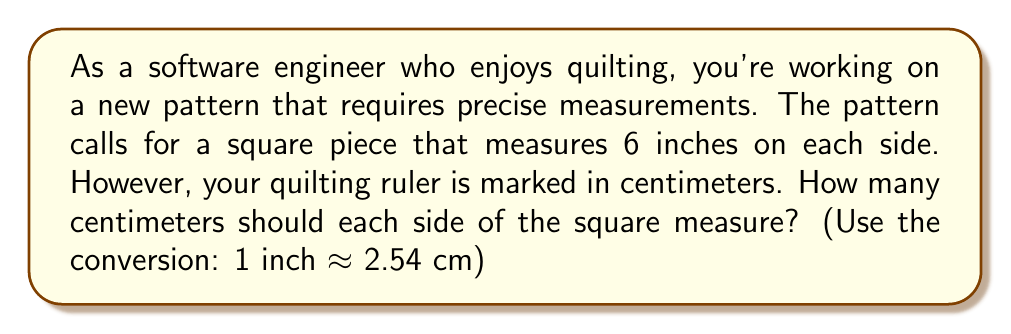Provide a solution to this math problem. To solve this problem, we need to convert 6 inches to centimeters. Let's break it down step-by-step:

1. We know that 1 inch is approximately equal to 2.54 centimeters.
   This can be expressed as a conversion factor: $1 \text{ inch} \approx 2.54 \text{ cm}$

2. We need to convert 6 inches to centimeters. We can set up the following proportion:
   $\frac{6 \text{ inches}}{1} = \frac{x \text{ cm}}{2.54 \text{ cm}}$

3. Cross-multiply to solve for $x$:
   $6 \cdot 2.54 = 1 \cdot x$

4. Simplify:
   $15.24 = x$

5. Therefore, 6 inches is equal to 15.24 centimeters.

To verify:
$6 \text{ inches} \cdot \frac{2.54 \text{ cm}}{1 \text{ inch}} = 15.24 \text{ cm}$

So, each side of the square should measure 15.24 cm.
Answer: $15.24 \text{ cm}$ 